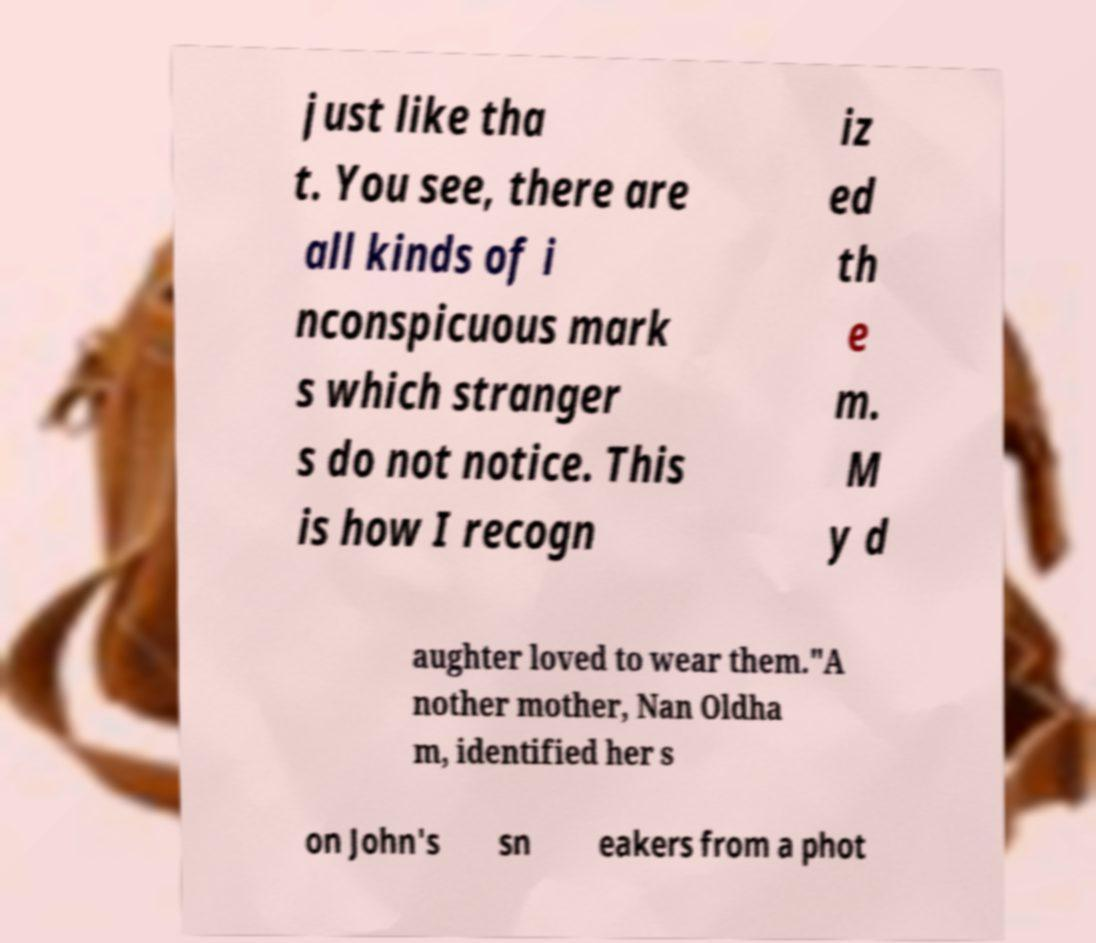For documentation purposes, I need the text within this image transcribed. Could you provide that? just like tha t. You see, there are all kinds of i nconspicuous mark s which stranger s do not notice. This is how I recogn iz ed th e m. M y d aughter loved to wear them."A nother mother, Nan Oldha m, identified her s on John's sn eakers from a phot 